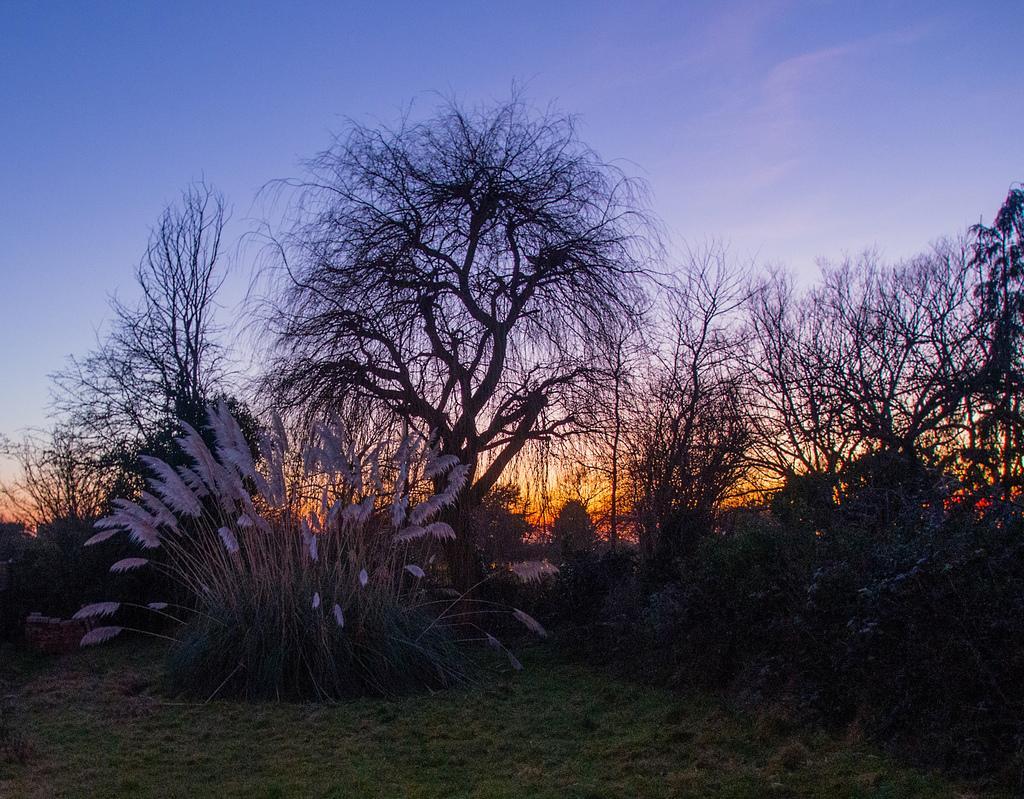Describe this image in one or two sentences. In the image we can see there are plants on the ground and the ground is covered with grass. Behind there are trees. 